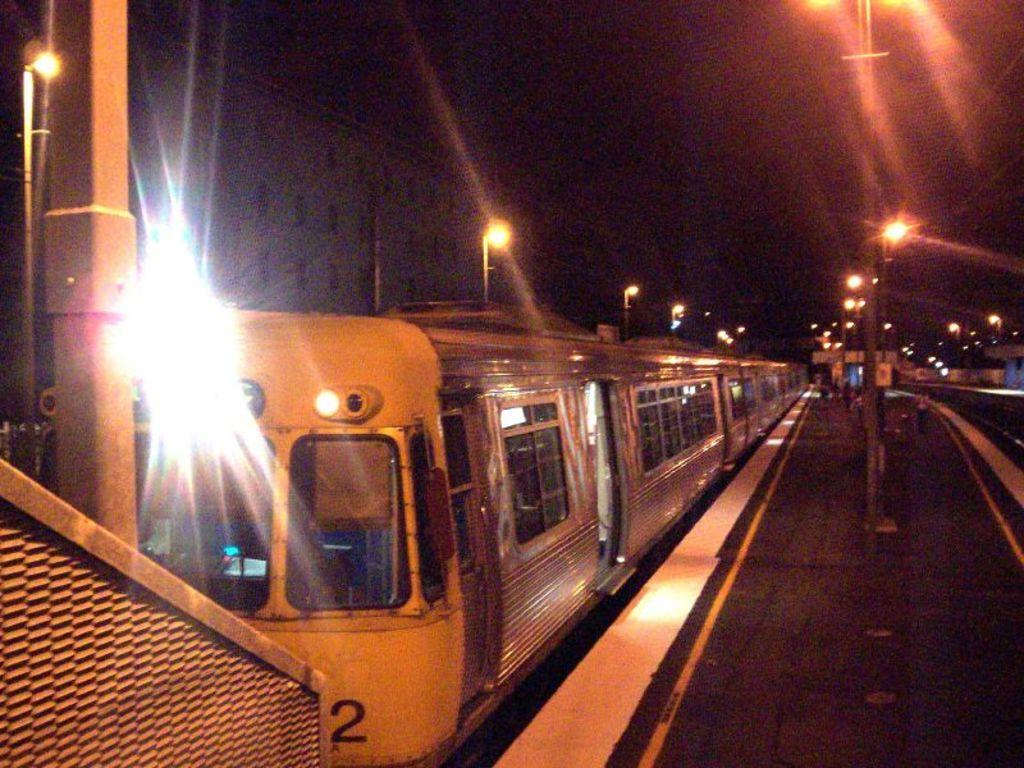<image>
Write a terse but informative summary of the picture. A train car has the number 2 on the back of it. 